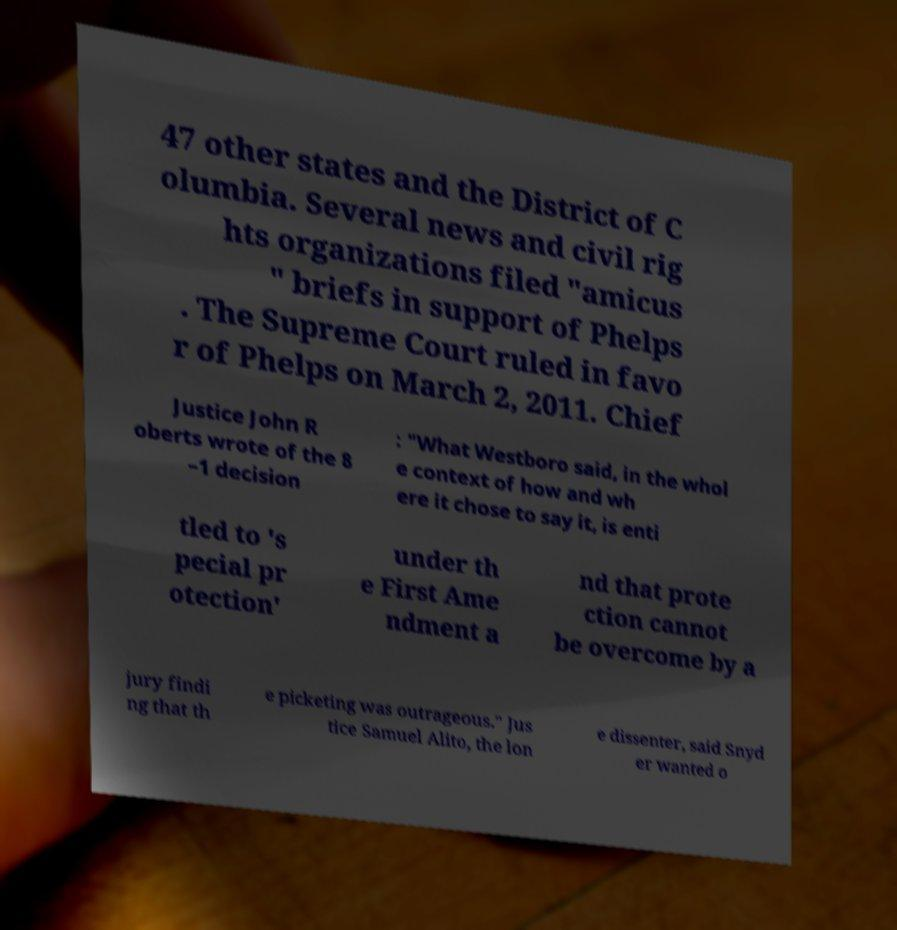What messages or text are displayed in this image? I need them in a readable, typed format. 47 other states and the District of C olumbia. Several news and civil rig hts organizations filed "amicus " briefs in support of Phelps . The Supreme Court ruled in favo r of Phelps on March 2, 2011. Chief Justice John R oberts wrote of the 8 –1 decision : "What Westboro said, in the whol e context of how and wh ere it chose to say it, is enti tled to 's pecial pr otection' under th e First Ame ndment a nd that prote ction cannot be overcome by a jury findi ng that th e picketing was outrageous." Jus tice Samuel Alito, the lon e dissenter, said Snyd er wanted o 